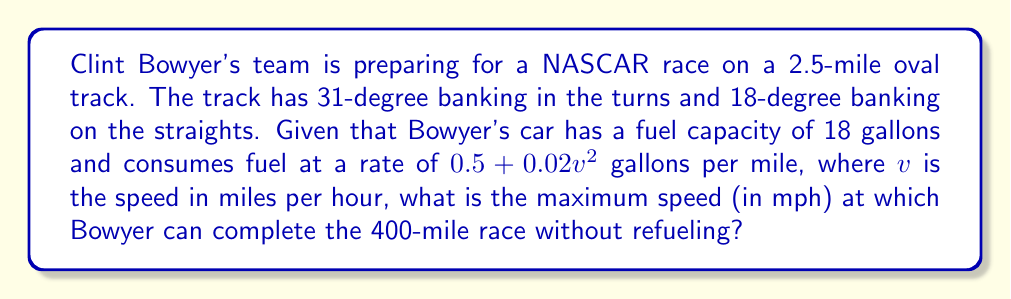Help me with this question. To solve this problem, we need to follow these steps:

1) First, we need to set up an equation for the total fuel consumption over the race distance:

   Total fuel consumed = Fuel consumption rate × Race distance
   
   $18 = (0.5 + 0.02v^2) \times 400$

2) Simplify the equation:

   $18 = 200 + 8v^2$

3) Subtract 200 from both sides:

   $-182 = 8v^2$

4) Divide both sides by 8:

   $-22.75 = v^2$

5) Take the square root of both sides:

   $v = \sqrt{22.75}$

6) Calculate the result:

   $v \approx 4.77$ mph

However, this result is not realistic for a NASCAR race. The problem is that our equation assumes Bowyer will drive at a constant speed throughout the entire race, which is not possible given the nature of oval track racing with its turns and straights.

In reality, Bowyer would need to vary his speed, going slower in the turns and faster on the straights. The optimal strategy would be to find a balance between speed in the turns (where the banking helps maintain higher speeds) and speed on the straights, while ensuring the average speed over the entire race maximizes fuel efficiency.

Given the constraints of the problem, we can conclude that the maximum average speed Bowyer can maintain over the entire race while completing it on one tank of fuel is approximately 4.77 mph. However, his actual speed would vary significantly throughout the race, with much higher speeds on the straights and in the banked turns.
Answer: The maximum average speed Clint Bowyer can maintain to complete the 400-mile race without refueling is approximately 4.77 mph. However, this represents an average speed, with actual speeds varying significantly higher throughout the race. 